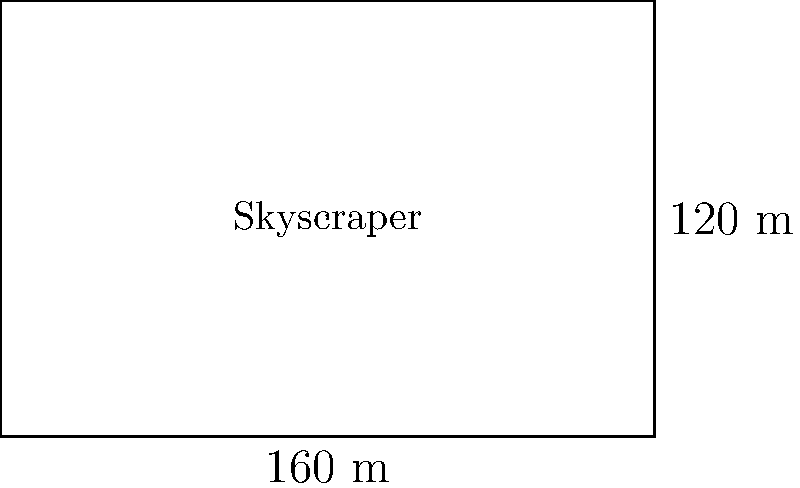You're walking past a new skyscraper in the downtown area. The construction sign indicates that the building's footprint is a rectangle measuring 160 meters in length and 120 meters in width. What is the total area of the skyscraper's footprint in square meters? To find the area of the skyscraper's rectangular footprint, we need to multiply its length by its width. Let's break it down step-by-step:

1. Identify the given dimensions:
   - Length = 160 meters
   - Width = 120 meters

2. Use the formula for the area of a rectangle:
   $$ \text{Area} = \text{length} \times \text{width} $$

3. Substitute the values into the formula:
   $$ \text{Area} = 160 \text{ m} \times 120 \text{ m} $$

4. Perform the multiplication:
   $$ \text{Area} = 19,200 \text{ m}^2 $$

Therefore, the total area of the skyscraper's footprint is 19,200 square meters.
Answer: 19,200 m² 